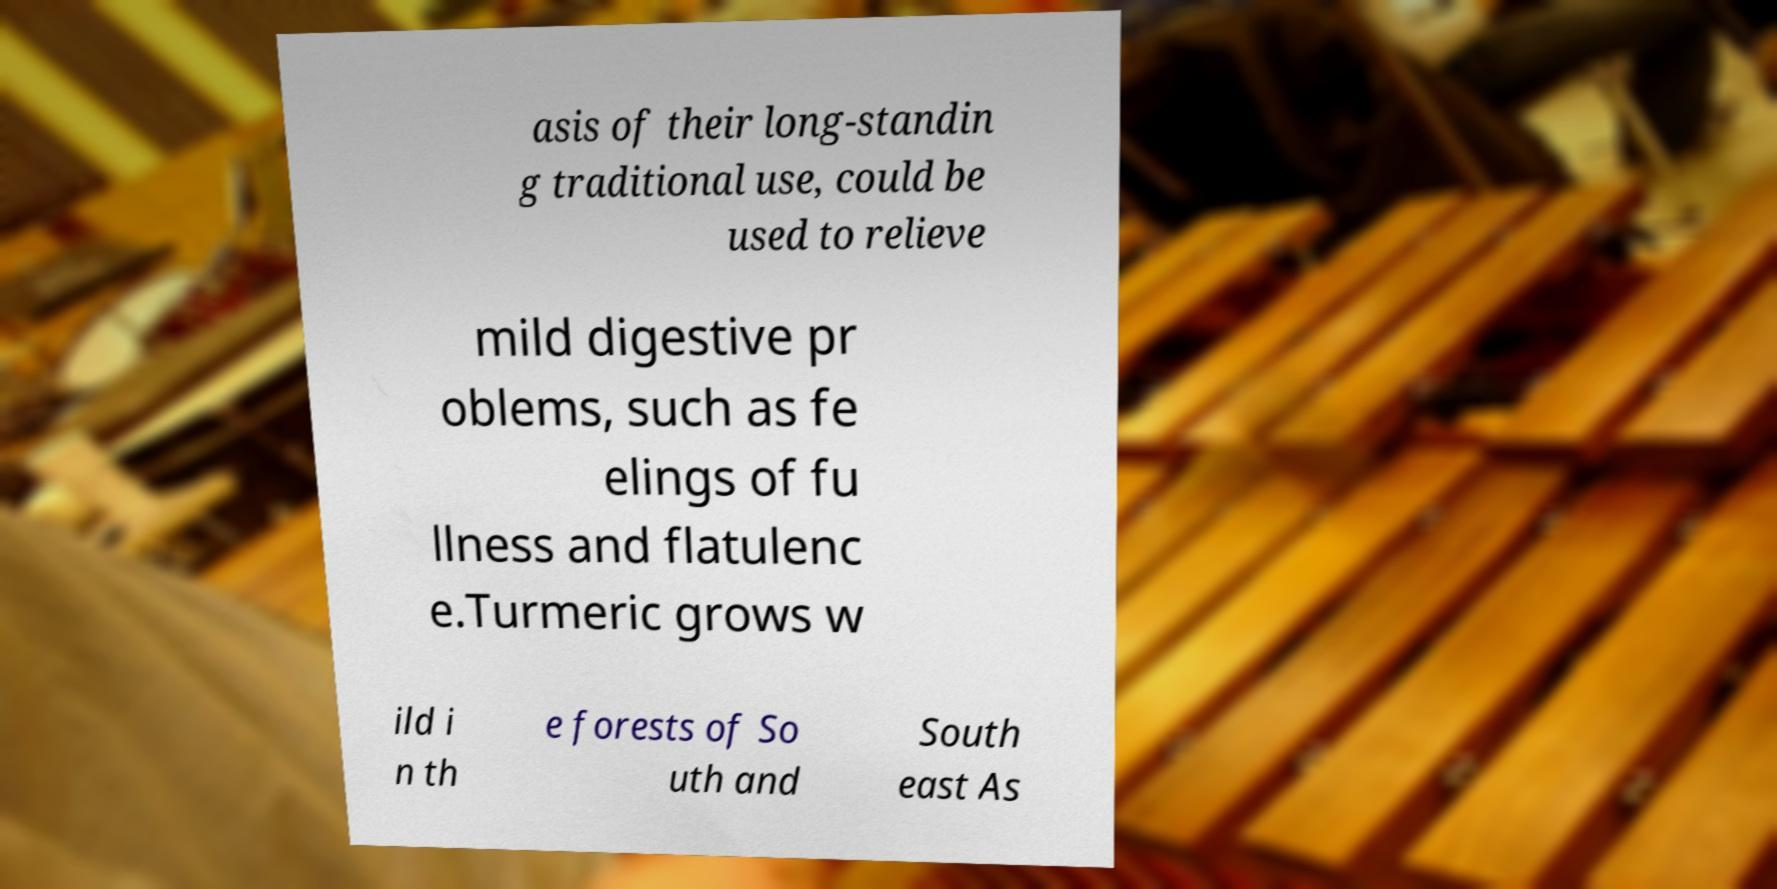Can you accurately transcribe the text from the provided image for me? asis of their long-standin g traditional use, could be used to relieve mild digestive pr oblems, such as fe elings of fu llness and flatulenc e.Turmeric grows w ild i n th e forests of So uth and South east As 